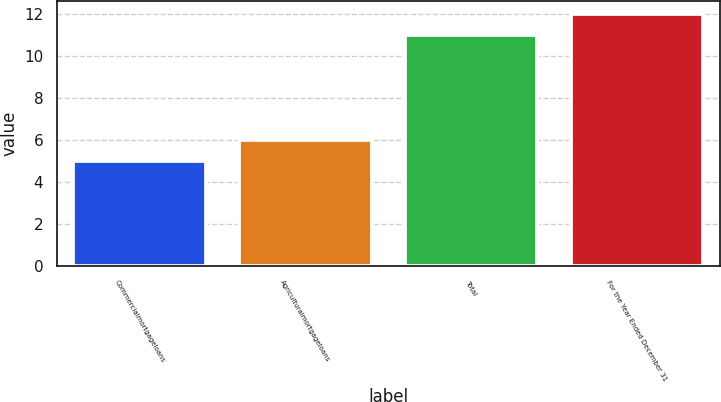Convert chart. <chart><loc_0><loc_0><loc_500><loc_500><bar_chart><fcel>Commercialmortgageloans<fcel>Agriculturalmortgageloans<fcel>Total<fcel>For the Year Ended December 31<nl><fcel>5<fcel>6<fcel>11<fcel>12<nl></chart> 